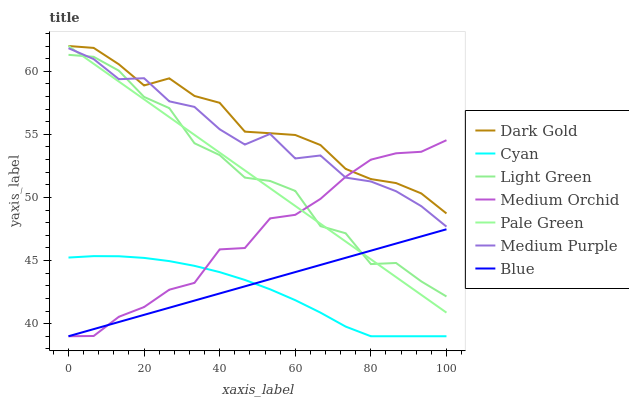Does Medium Orchid have the minimum area under the curve?
Answer yes or no. No. Does Medium Orchid have the maximum area under the curve?
Answer yes or no. No. Is Dark Gold the smoothest?
Answer yes or no. No. Is Dark Gold the roughest?
Answer yes or no. No. Does Dark Gold have the lowest value?
Answer yes or no. No. Does Medium Orchid have the highest value?
Answer yes or no. No. Is Blue less than Dark Gold?
Answer yes or no. Yes. Is Medium Purple greater than Cyan?
Answer yes or no. Yes. Does Blue intersect Dark Gold?
Answer yes or no. No. 